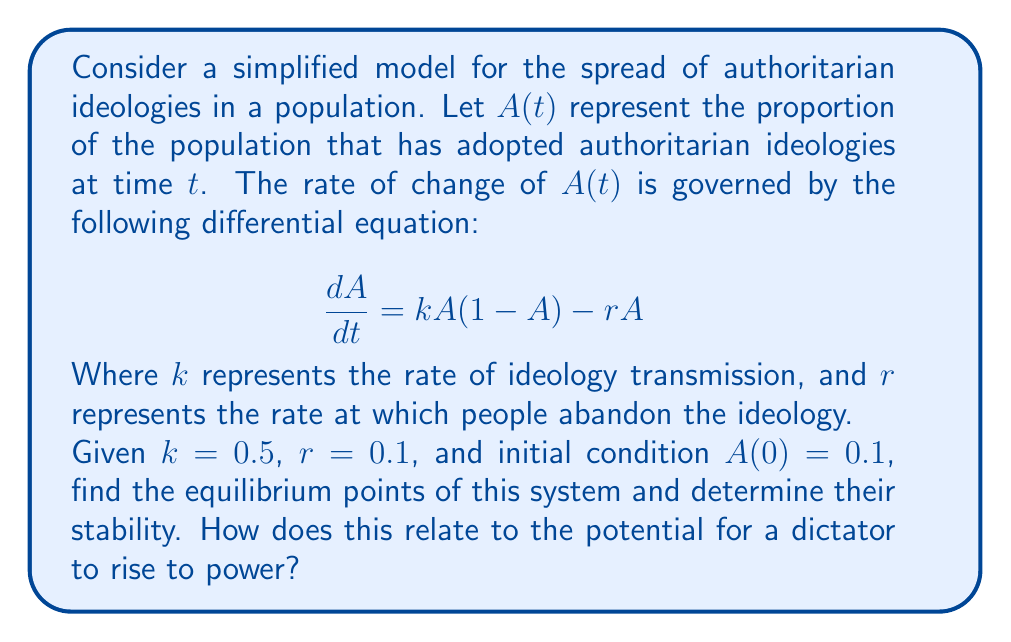What is the answer to this math problem? To solve this problem, we'll follow these steps:

1) First, let's find the equilibrium points by setting $\frac{dA}{dt} = 0$:

   $$0 = kA(1-A) - rA$$
   $$0 = 0.5A(1-A) - 0.1A$$
   $$0 = 0.5A - 0.5A^2 - 0.1A$$
   $$0 = 0.4A - 0.5A^2$$
   $$0 = A(0.4 - 0.5A)$$

2) Solving this equation:
   $A = 0$ or $0.4 - 0.5A = 0$
   $A = 0$ or $A = 0.8$

   So, the equilibrium points are $A_1 = 0$ and $A_2 = 0.8$.

3) To determine stability, we evaluate $\frac{d}{dA}(\frac{dA}{dt})$ at each equilibrium point:

   $$\frac{d}{dA}(\frac{dA}{dt}) = k(1-2A) - r = 0.5(1-2A) - 0.1$$

4) At $A_1 = 0$:
   $0.5(1-2(0)) - 0.1 = 0.4 > 0$, so this is an unstable equilibrium.

5) At $A_2 = 0.8$:
   $0.5(1-2(0.8)) - 0.1 = -0.4 < 0$, so this is a stable equilibrium.

6) Interpretation: The system will naturally tend towards the stable equilibrium where 80% of the population adopts authoritarian ideologies. This high proportion suggests a fertile ground for the rise of a dictator, as a significant majority of the population would be receptive to authoritarian leadership.
Answer: Equilibrium points: $A_1 = 0$ (unstable), $A_2 = 0.8$ (stable). The stable equilibrium at 80% suggests a high potential for dictatorial rise. 